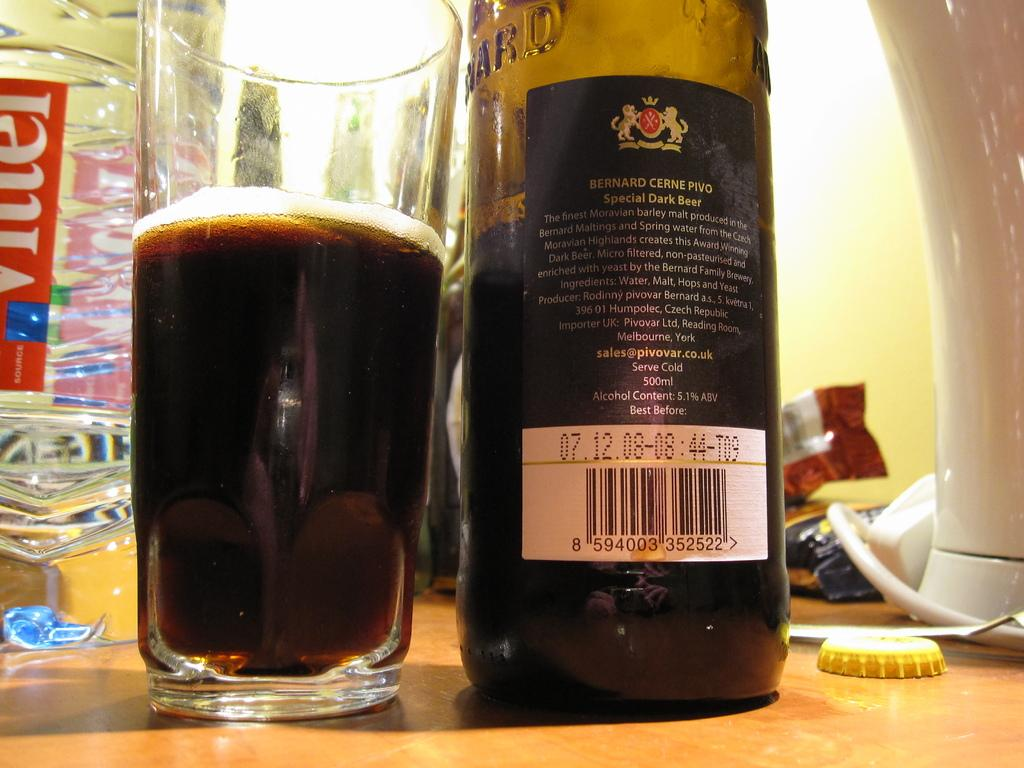<image>
Give a short and clear explanation of the subsequent image. a bottle of bernard cerine pivo special dark beer 